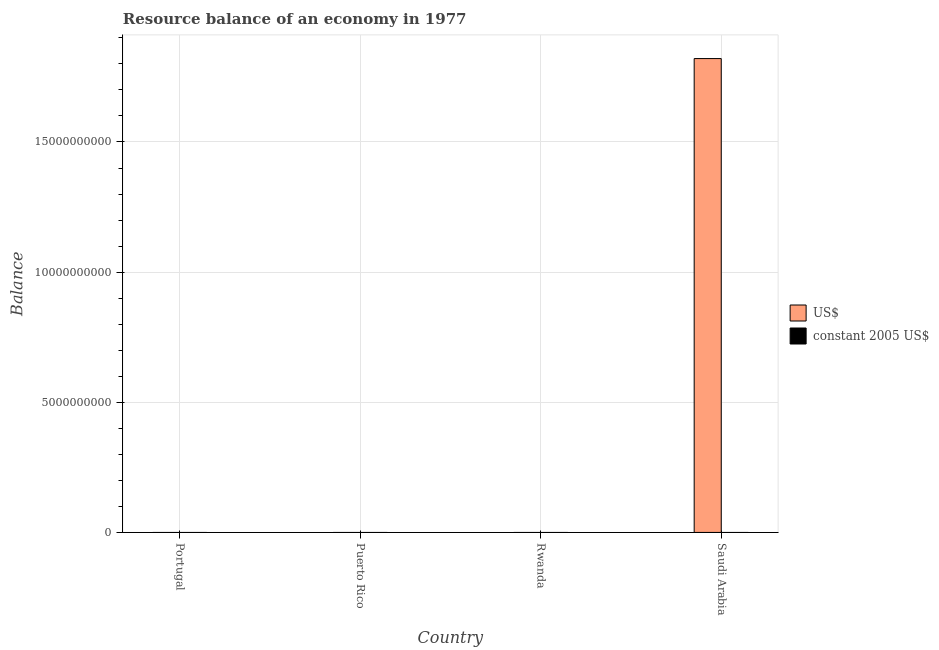How many different coloured bars are there?
Provide a short and direct response. 1. What is the label of the 2nd group of bars from the left?
Make the answer very short. Puerto Rico. In how many cases, is the number of bars for a given country not equal to the number of legend labels?
Make the answer very short. 4. Across all countries, what is the maximum resource balance in us$?
Provide a succinct answer. 1.82e+1. In which country was the resource balance in us$ maximum?
Your answer should be compact. Saudi Arabia. What is the total resource balance in us$ in the graph?
Give a very brief answer. 1.82e+1. What is the average resource balance in us$ per country?
Ensure brevity in your answer.  4.55e+09. In how many countries, is the resource balance in us$ greater than 18000000000 units?
Provide a short and direct response. 1. What is the difference between the highest and the lowest resource balance in us$?
Provide a short and direct response. 1.82e+1. Are all the bars in the graph horizontal?
Provide a short and direct response. No. How many countries are there in the graph?
Your answer should be compact. 4. What is the difference between two consecutive major ticks on the Y-axis?
Your answer should be very brief. 5.00e+09. Does the graph contain any zero values?
Provide a short and direct response. Yes. Does the graph contain grids?
Your answer should be very brief. Yes. What is the title of the graph?
Offer a very short reply. Resource balance of an economy in 1977. Does "Primary education" appear as one of the legend labels in the graph?
Your answer should be compact. No. What is the label or title of the Y-axis?
Your answer should be very brief. Balance. What is the Balance in US$ in Portugal?
Your response must be concise. 0. What is the Balance of US$ in Rwanda?
Provide a succinct answer. 0. What is the Balance of US$ in Saudi Arabia?
Ensure brevity in your answer.  1.82e+1. Across all countries, what is the maximum Balance of US$?
Your answer should be very brief. 1.82e+1. Across all countries, what is the minimum Balance of US$?
Provide a short and direct response. 0. What is the total Balance of US$ in the graph?
Provide a succinct answer. 1.82e+1. What is the average Balance of US$ per country?
Give a very brief answer. 4.55e+09. What is the difference between the highest and the lowest Balance of US$?
Offer a very short reply. 1.82e+1. 